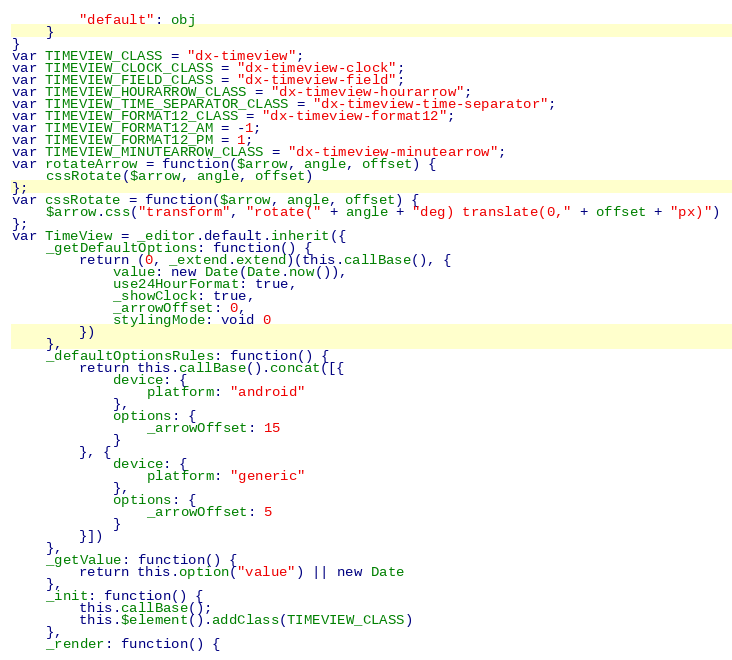<code> <loc_0><loc_0><loc_500><loc_500><_JavaScript_>        "default": obj
    }
}
var TIMEVIEW_CLASS = "dx-timeview";
var TIMEVIEW_CLOCK_CLASS = "dx-timeview-clock";
var TIMEVIEW_FIELD_CLASS = "dx-timeview-field";
var TIMEVIEW_HOURARROW_CLASS = "dx-timeview-hourarrow";
var TIMEVIEW_TIME_SEPARATOR_CLASS = "dx-timeview-time-separator";
var TIMEVIEW_FORMAT12_CLASS = "dx-timeview-format12";
var TIMEVIEW_FORMAT12_AM = -1;
var TIMEVIEW_FORMAT12_PM = 1;
var TIMEVIEW_MINUTEARROW_CLASS = "dx-timeview-minutearrow";
var rotateArrow = function($arrow, angle, offset) {
    cssRotate($arrow, angle, offset)
};
var cssRotate = function($arrow, angle, offset) {
    $arrow.css("transform", "rotate(" + angle + "deg) translate(0," + offset + "px)")
};
var TimeView = _editor.default.inherit({
    _getDefaultOptions: function() {
        return (0, _extend.extend)(this.callBase(), {
            value: new Date(Date.now()),
            use24HourFormat: true,
            _showClock: true,
            _arrowOffset: 0,
            stylingMode: void 0
        })
    },
    _defaultOptionsRules: function() {
        return this.callBase().concat([{
            device: {
                platform: "android"
            },
            options: {
                _arrowOffset: 15
            }
        }, {
            device: {
                platform: "generic"
            },
            options: {
                _arrowOffset: 5
            }
        }])
    },
    _getValue: function() {
        return this.option("value") || new Date
    },
    _init: function() {
        this.callBase();
        this.$element().addClass(TIMEVIEW_CLASS)
    },
    _render: function() {</code> 